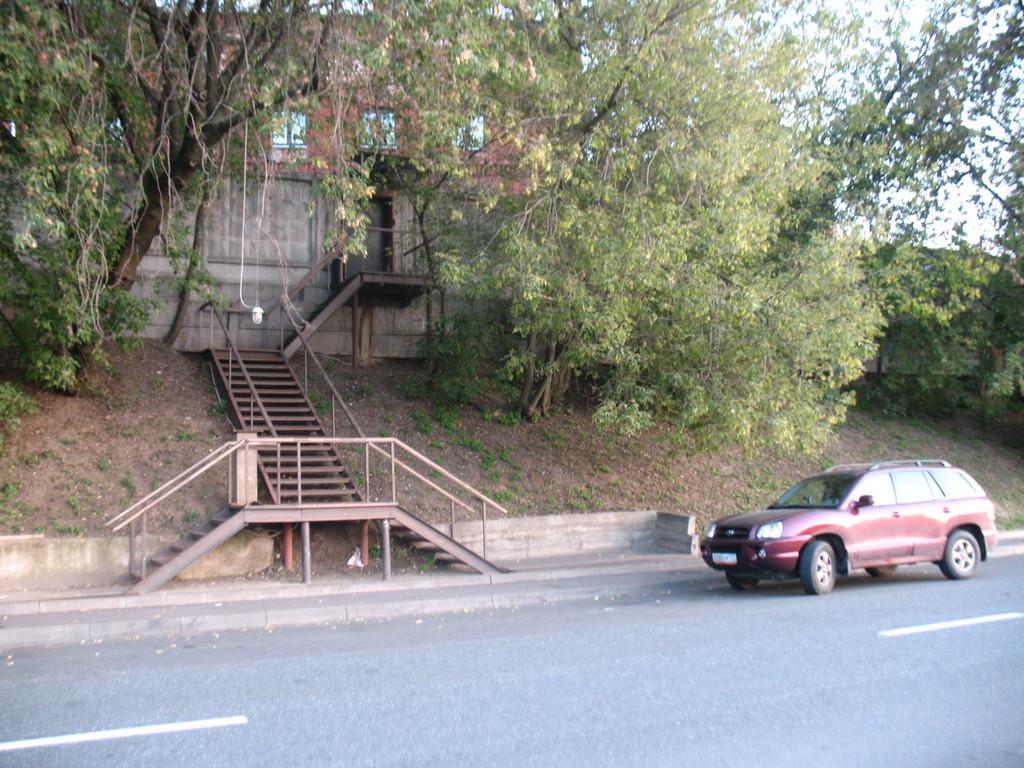In one or two sentences, can you explain what this image depicts? In the foreground of this image, there is a vehicle on the road. In the background, there are stairs, trees, building and the sky. 